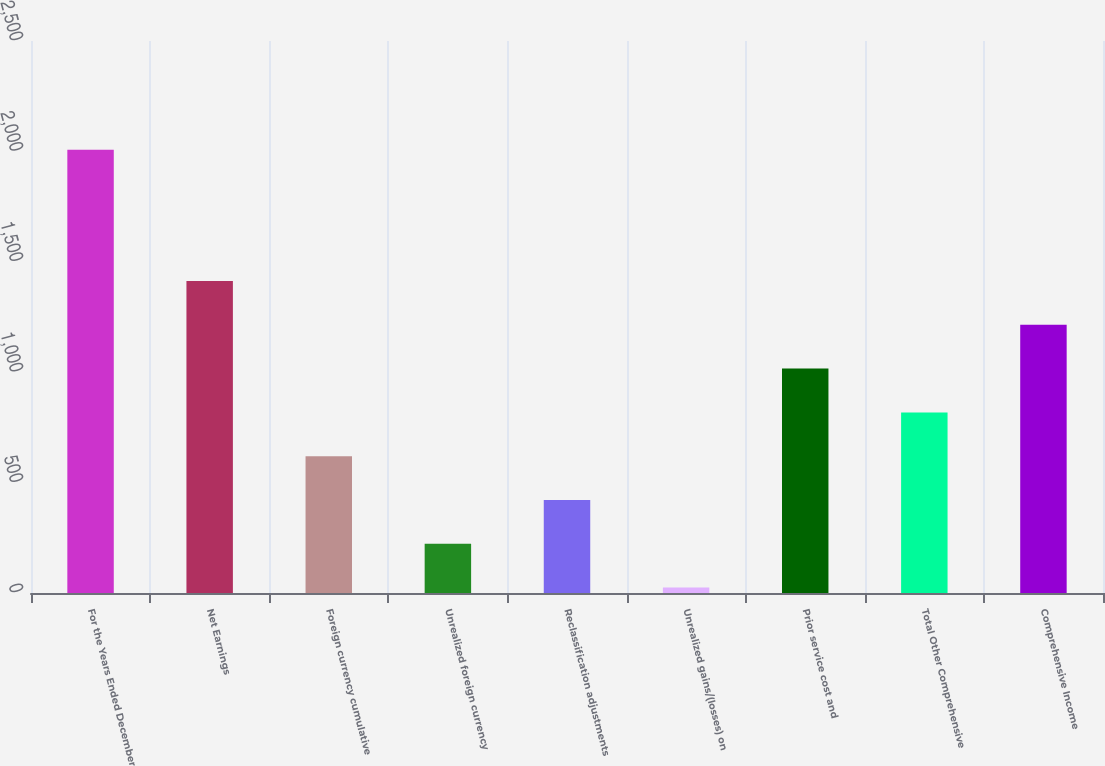Convert chart to OTSL. <chart><loc_0><loc_0><loc_500><loc_500><bar_chart><fcel>For the Years Ended December<fcel>Net Earnings<fcel>Foreign currency cumulative<fcel>Unrealized foreign currency<fcel>Reclassification adjustments<fcel>Unrealized gains/(losses) on<fcel>Prior service cost and<fcel>Total Other Comprehensive<fcel>Comprehensive Income<nl><fcel>2008<fcel>1412.92<fcel>619.48<fcel>222.76<fcel>421.12<fcel>24.4<fcel>1016.2<fcel>817.84<fcel>1214.56<nl></chart> 